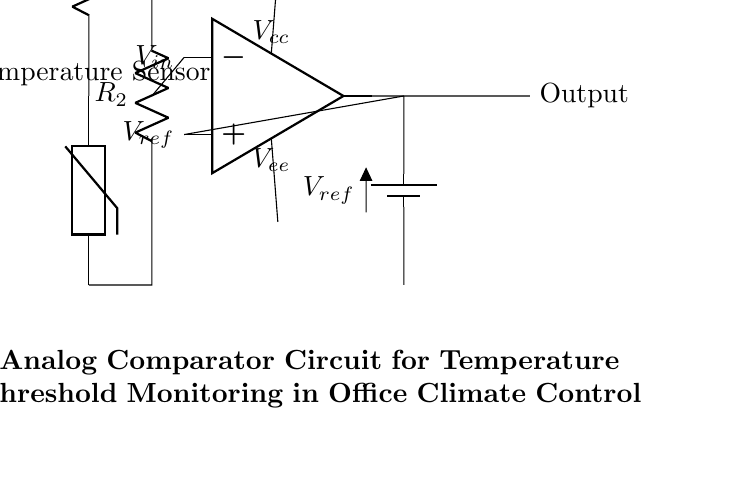What is the type of temperature sensor used in this circuit? The circuit diagram shows a thermistor, which is a type of temperature sensor that changes its resistance with temperature.
Answer: Thermistor What is the purpose of the operational amplifier in the circuit? The operational amplifier is configured as a comparator, comparing the input voltage from the thermistor to a reference voltage to determine whether to switch an output state.
Answer: Comparator What is the reference voltage indicated in the circuit? The reference voltage is marked as V_ref and is provided by a battery in the circuit.
Answer: V_ref What do the resistors R1 and R2 form in this circuit? Resistors R1 and R2 are part of a voltage divider that sets the input voltage level for the operational amplifier relative to temperature changes detected by the thermistor.
Answer: Voltage divider If the input voltage is lower than the reference voltage, what will be the output state of the comparator? When the input voltage from the thermistor is less than the reference voltage, the output of the comparator typically goes low, indicating the temperature is below the threshold set.
Answer: Low What are the supply voltages for the operational amplifier indicated in the circuit? The operational amplifier has a positive supply voltage (V_cc) and a negative supply voltage (V_ee), which are necessary for its operation.
Answer: V_cc and V_ee What happens to the circuit if the temperature exceeds the threshold set by the reference voltage? If the temperature exceeds the threshold (meaning the input voltage is higher than V_ref), the output of the comparator goes high, signaling that the temperature is above the acceptable level.
Answer: Goes high 